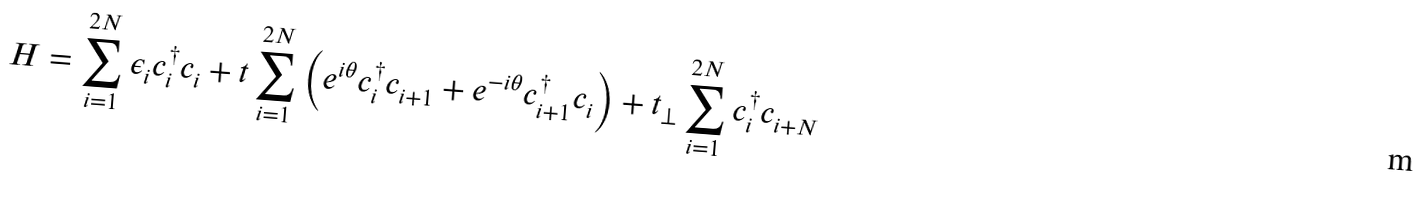Convert formula to latex. <formula><loc_0><loc_0><loc_500><loc_500>H = \sum _ { i = 1 } ^ { 2 N } \epsilon _ { i } c _ { i } ^ { \dagger } c _ { i } + t \sum _ { i = 1 } ^ { 2 N } \left ( e ^ { i \theta } c _ { i } ^ { \dagger } c _ { i + 1 } + e ^ { - i \theta } c _ { i + 1 } ^ { \dagger } c _ { i } \right ) + t _ { \bot } \sum _ { i = 1 } ^ { 2 N } c _ { i } ^ { \dagger } c _ { i + N }</formula> 